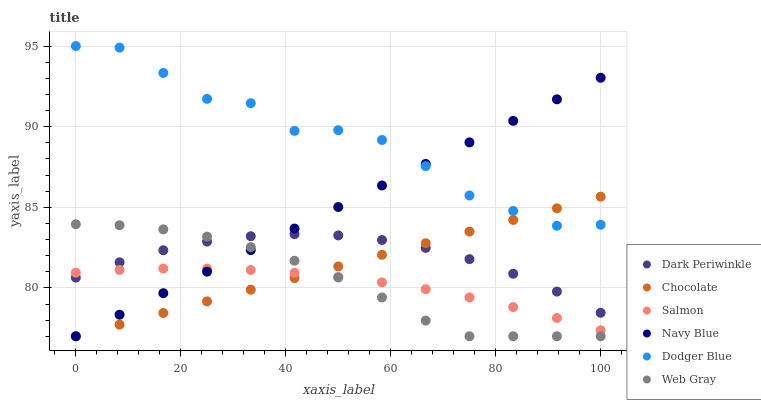Does Salmon have the minimum area under the curve?
Answer yes or no. Yes. Does Dodger Blue have the maximum area under the curve?
Answer yes or no. Yes. Does Navy Blue have the minimum area under the curve?
Answer yes or no. No. Does Navy Blue have the maximum area under the curve?
Answer yes or no. No. Is Chocolate the smoothest?
Answer yes or no. Yes. Is Dodger Blue the roughest?
Answer yes or no. Yes. Is Navy Blue the smoothest?
Answer yes or no. No. Is Navy Blue the roughest?
Answer yes or no. No. Does Web Gray have the lowest value?
Answer yes or no. Yes. Does Salmon have the lowest value?
Answer yes or no. No. Does Dodger Blue have the highest value?
Answer yes or no. Yes. Does Navy Blue have the highest value?
Answer yes or no. No. Is Web Gray less than Dodger Blue?
Answer yes or no. Yes. Is Dodger Blue greater than Salmon?
Answer yes or no. Yes. Does Dark Periwinkle intersect Web Gray?
Answer yes or no. Yes. Is Dark Periwinkle less than Web Gray?
Answer yes or no. No. Is Dark Periwinkle greater than Web Gray?
Answer yes or no. No. Does Web Gray intersect Dodger Blue?
Answer yes or no. No. 